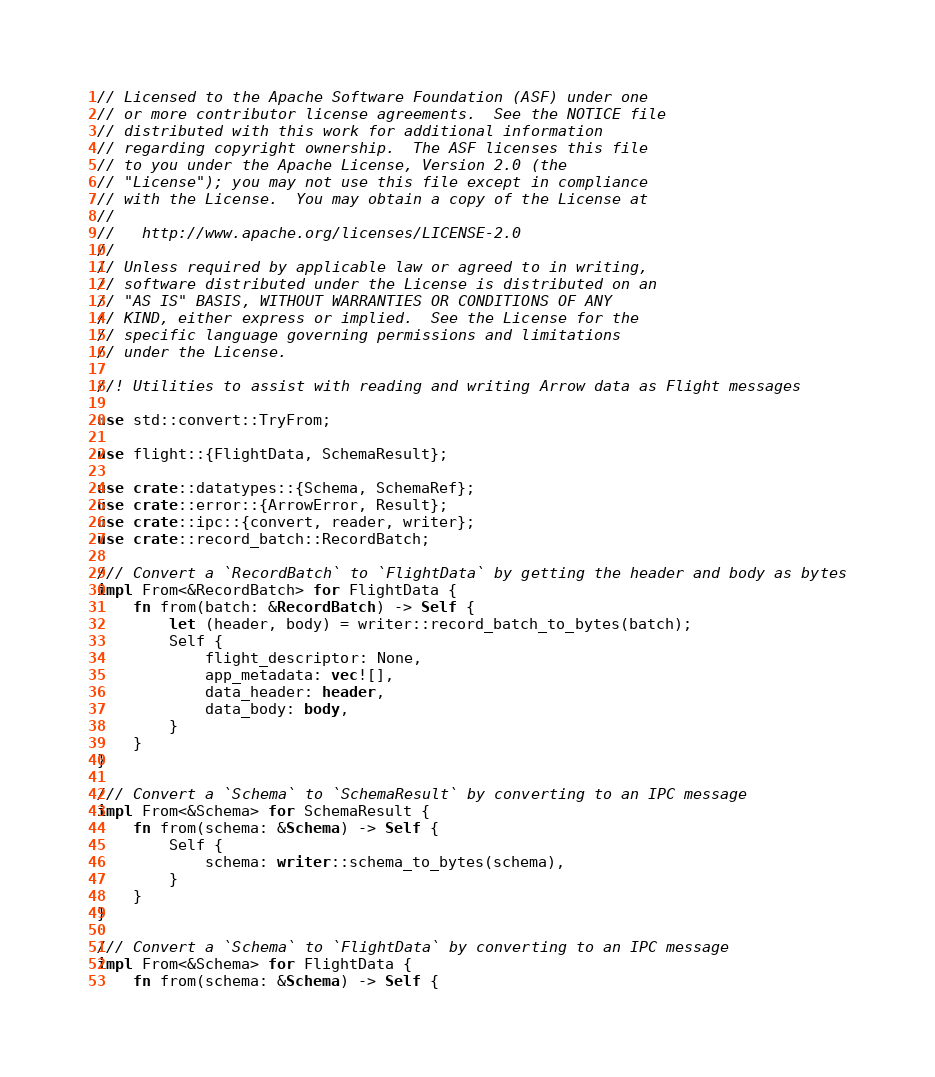<code> <loc_0><loc_0><loc_500><loc_500><_Rust_>// Licensed to the Apache Software Foundation (ASF) under one
// or more contributor license agreements.  See the NOTICE file
// distributed with this work for additional information
// regarding copyright ownership.  The ASF licenses this file
// to you under the Apache License, Version 2.0 (the
// "License"); you may not use this file except in compliance
// with the License.  You may obtain a copy of the License at
//
//   http://www.apache.org/licenses/LICENSE-2.0
//
// Unless required by applicable law or agreed to in writing,
// software distributed under the License is distributed on an
// "AS IS" BASIS, WITHOUT WARRANTIES OR CONDITIONS OF ANY
// KIND, either express or implied.  See the License for the
// specific language governing permissions and limitations
// under the License.

//! Utilities to assist with reading and writing Arrow data as Flight messages

use std::convert::TryFrom;

use flight::{FlightData, SchemaResult};

use crate::datatypes::{Schema, SchemaRef};
use crate::error::{ArrowError, Result};
use crate::ipc::{convert, reader, writer};
use crate::record_batch::RecordBatch;

/// Convert a `RecordBatch` to `FlightData` by getting the header and body as bytes
impl From<&RecordBatch> for FlightData {
    fn from(batch: &RecordBatch) -> Self {
        let (header, body) = writer::record_batch_to_bytes(batch);
        Self {
            flight_descriptor: None,
            app_metadata: vec![],
            data_header: header,
            data_body: body,
        }
    }
}

/// Convert a `Schema` to `SchemaResult` by converting to an IPC message
impl From<&Schema> for SchemaResult {
    fn from(schema: &Schema) -> Self {
        Self {
            schema: writer::schema_to_bytes(schema),
        }
    }
}

/// Convert a `Schema` to `FlightData` by converting to an IPC message
impl From<&Schema> for FlightData {
    fn from(schema: &Schema) -> Self {</code> 